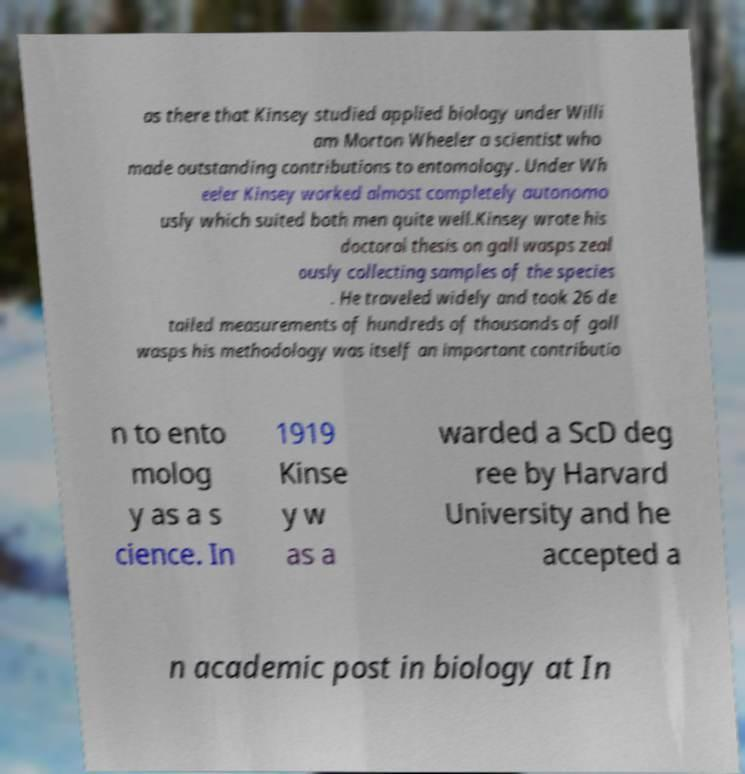What messages or text are displayed in this image? I need them in a readable, typed format. as there that Kinsey studied applied biology under Willi am Morton Wheeler a scientist who made outstanding contributions to entomology. Under Wh eeler Kinsey worked almost completely autonomo usly which suited both men quite well.Kinsey wrote his doctoral thesis on gall wasps zeal ously collecting samples of the species . He traveled widely and took 26 de tailed measurements of hundreds of thousands of gall wasps his methodology was itself an important contributio n to ento molog y as a s cience. In 1919 Kinse y w as a warded a ScD deg ree by Harvard University and he accepted a n academic post in biology at In 